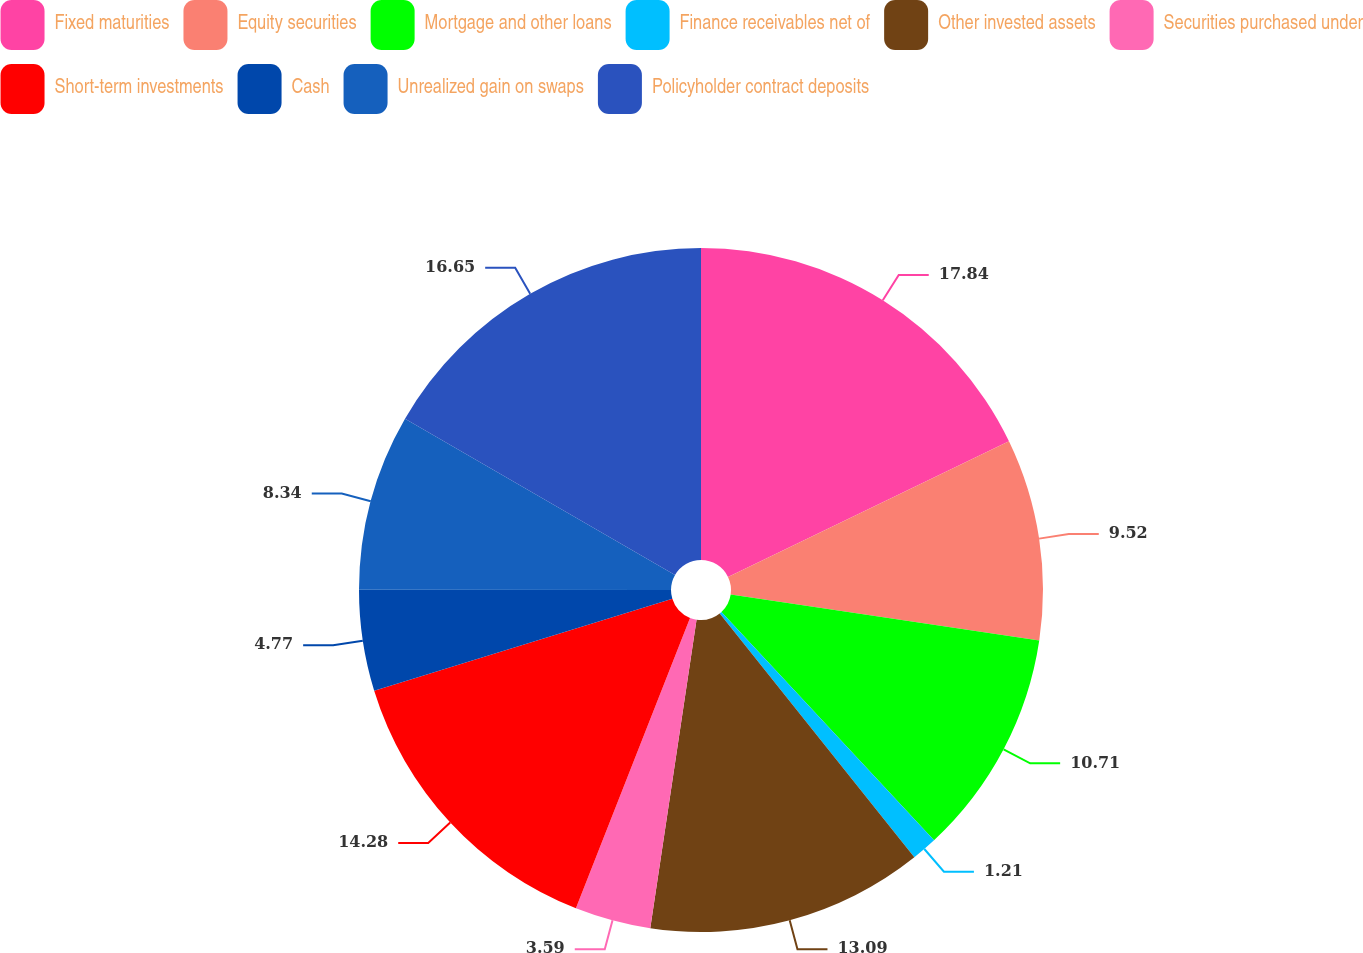<chart> <loc_0><loc_0><loc_500><loc_500><pie_chart><fcel>Fixed maturities<fcel>Equity securities<fcel>Mortgage and other loans<fcel>Finance receivables net of<fcel>Other invested assets<fcel>Securities purchased under<fcel>Short-term investments<fcel>Cash<fcel>Unrealized gain on swaps<fcel>Policyholder contract deposits<nl><fcel>17.84%<fcel>9.52%<fcel>10.71%<fcel>1.21%<fcel>13.09%<fcel>3.59%<fcel>14.28%<fcel>4.77%<fcel>8.34%<fcel>16.65%<nl></chart> 